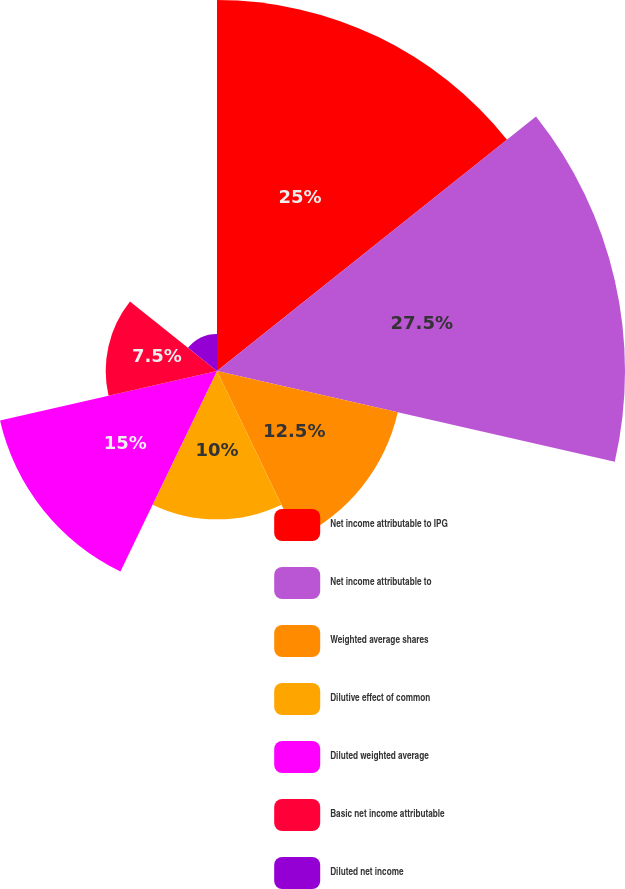<chart> <loc_0><loc_0><loc_500><loc_500><pie_chart><fcel>Net income attributable to IPG<fcel>Net income attributable to<fcel>Weighted average shares<fcel>Dilutive effect of common<fcel>Diluted weighted average<fcel>Basic net income attributable<fcel>Diluted net income<nl><fcel>25.0%<fcel>27.5%<fcel>12.5%<fcel>10.0%<fcel>15.0%<fcel>7.5%<fcel>2.5%<nl></chart> 